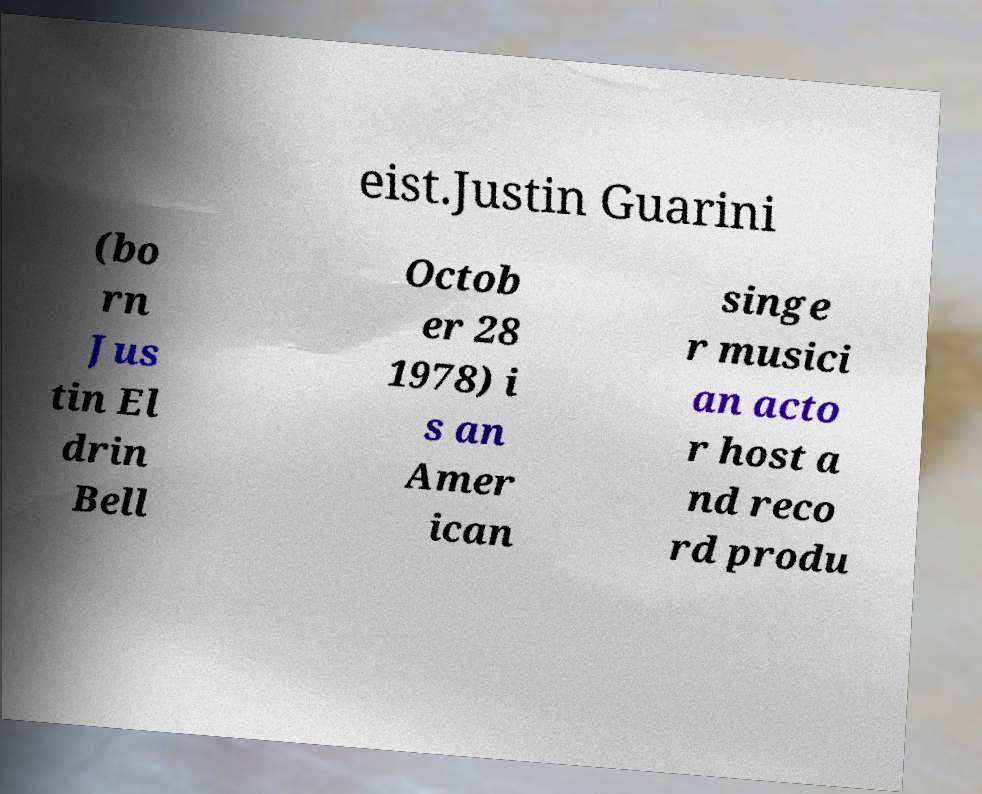For documentation purposes, I need the text within this image transcribed. Could you provide that? eist.Justin Guarini (bo rn Jus tin El drin Bell Octob er 28 1978) i s an Amer ican singe r musici an acto r host a nd reco rd produ 